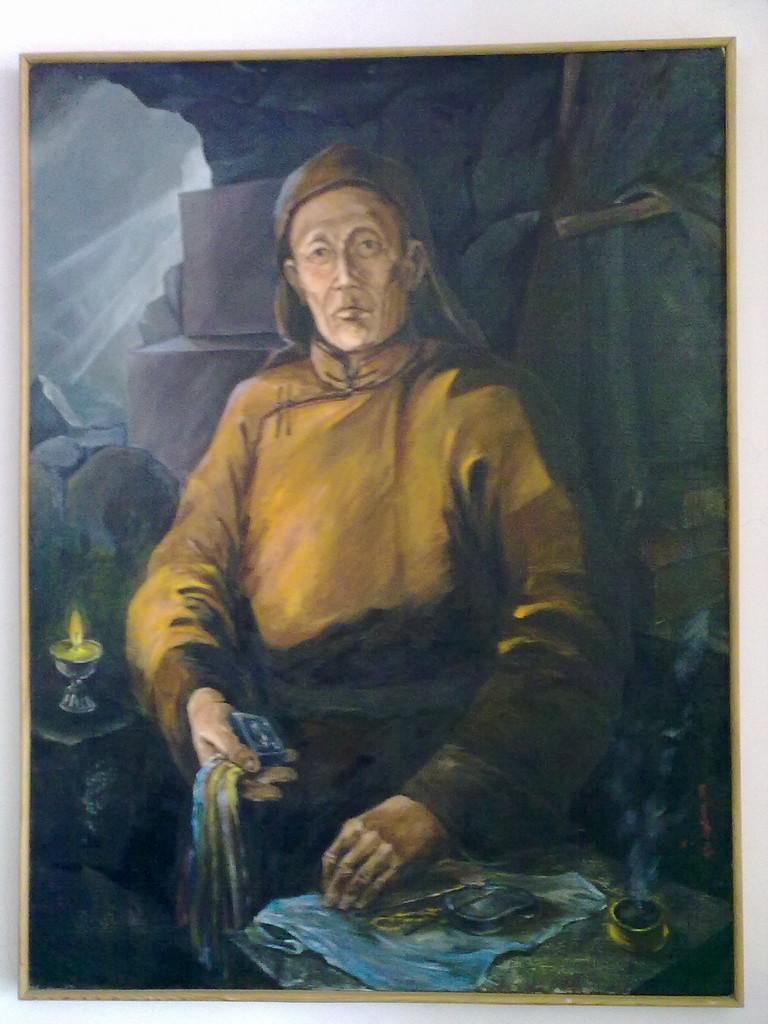What is the main subject of the image? There is a painting in the image. What is the person in the painting doing? The person in the painting is holding a cloth in their hands. What objects can be seen in the background of the painting? The painting includes lamps and rocks in the background. What type of sound can be heard coming from the rocks in the painting? There is no sound present in the image, as it is a painting and not a real-life scene. 